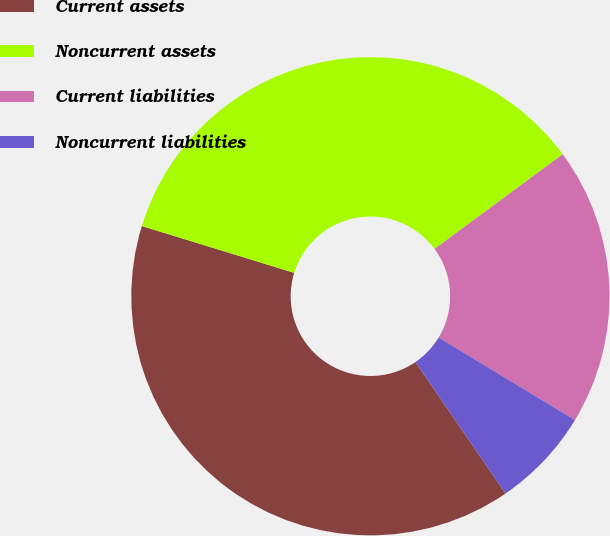Convert chart to OTSL. <chart><loc_0><loc_0><loc_500><loc_500><pie_chart><fcel>Current assets<fcel>Noncurrent assets<fcel>Current liabilities<fcel>Noncurrent liabilities<nl><fcel>39.3%<fcel>35.13%<fcel>18.78%<fcel>6.78%<nl></chart> 